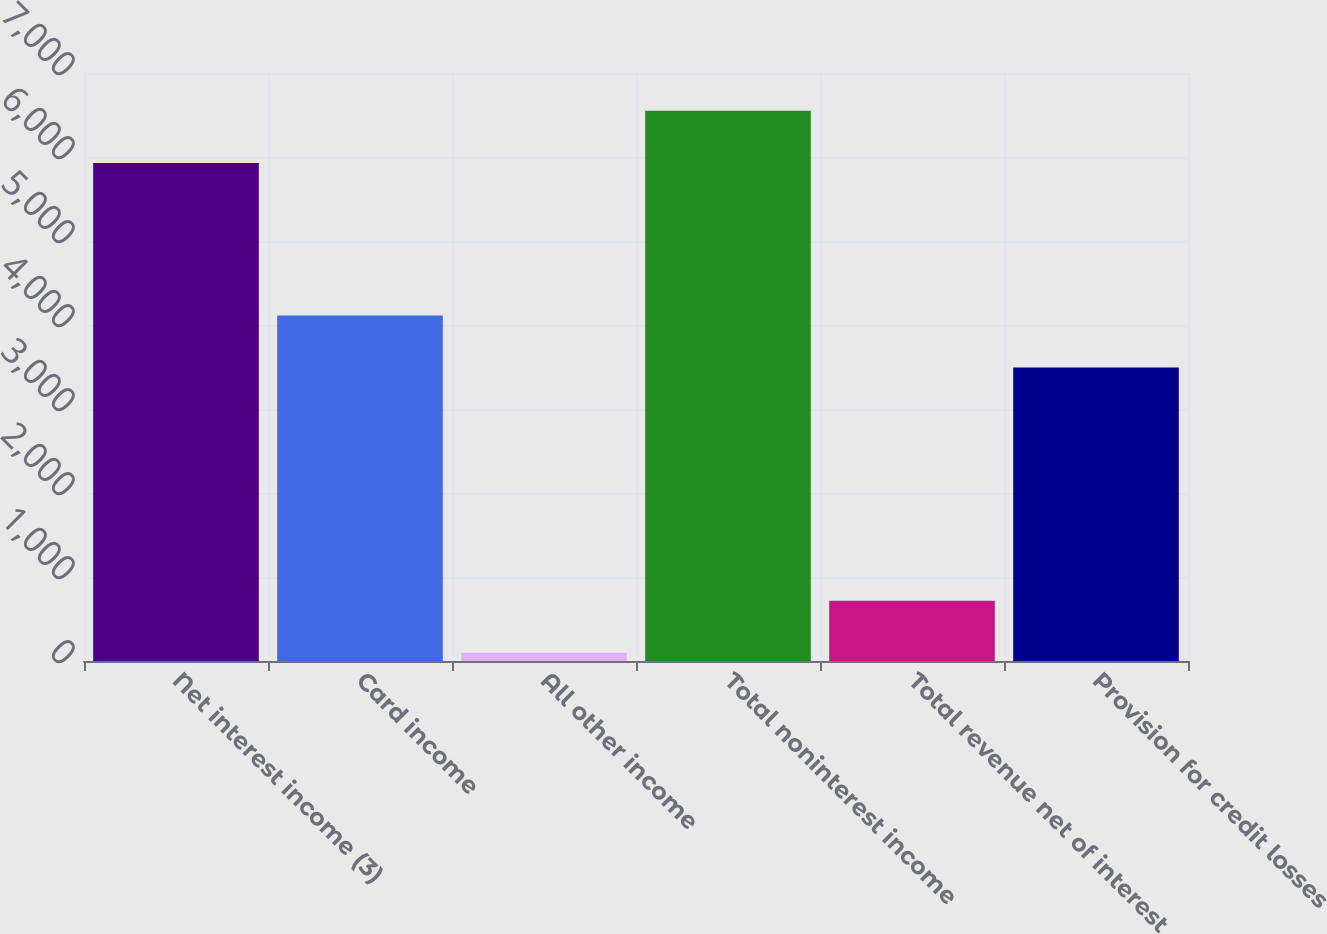Convert chart. <chart><loc_0><loc_0><loc_500><loc_500><bar_chart><fcel>Net interest income (3)<fcel>Card income<fcel>All other income<fcel>Total noninterest income<fcel>Total revenue net of interest<fcel>Provision for credit losses<nl><fcel>5930<fcel>4113.2<fcel>98<fcel>6549.2<fcel>717.2<fcel>3494<nl></chart> 